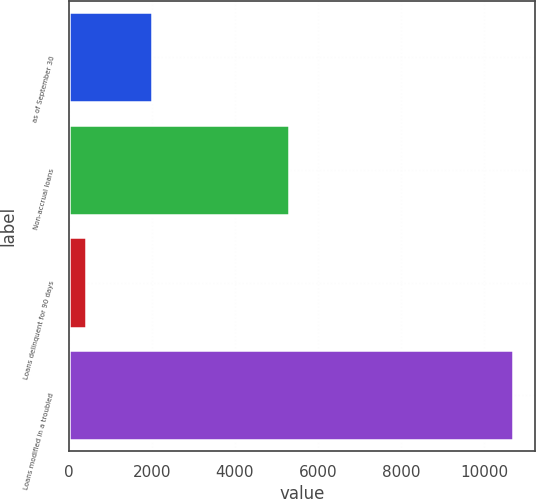Convert chart to OTSL. <chart><loc_0><loc_0><loc_500><loc_500><bar_chart><fcel>as of September 30<fcel>Non-accrual loans<fcel>Loans delinquent for 90 days<fcel>Loans modified in a troubled<nl><fcel>2010<fcel>5305<fcel>411<fcel>10690<nl></chart> 